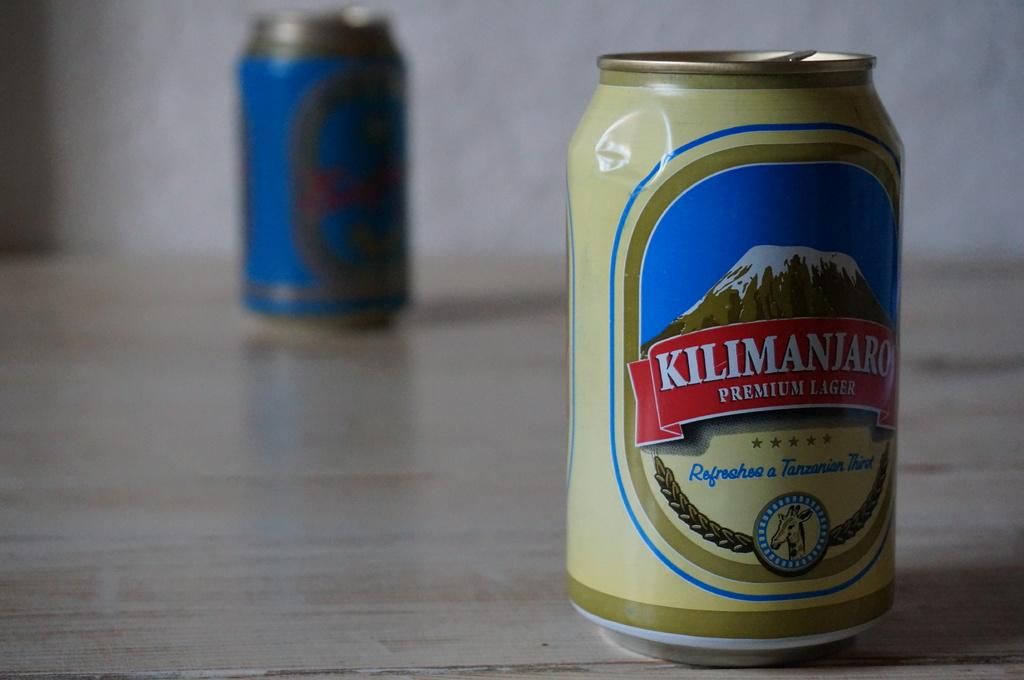Provide a one-sentence caption for the provided image. The can of Kilimanjaro lager has a little dent in it, toward the top. 